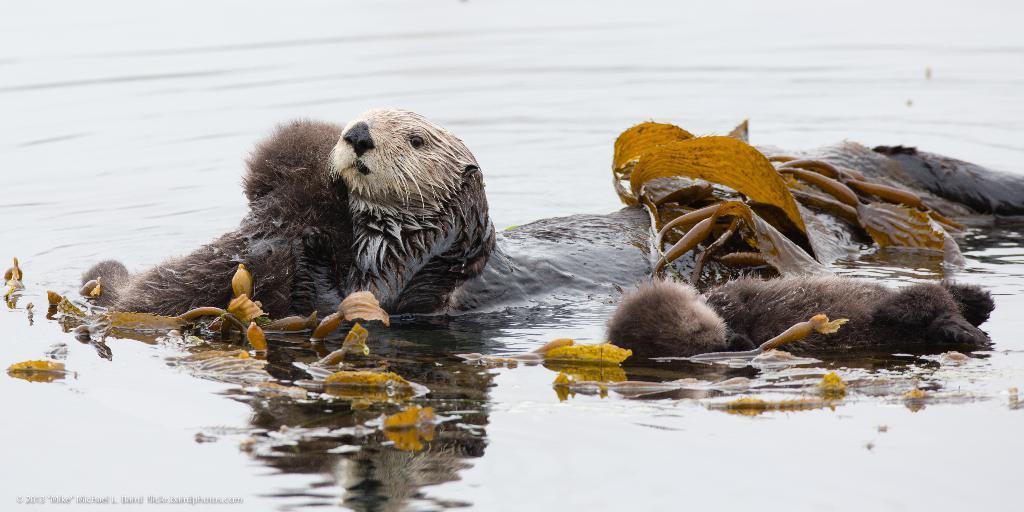Please provide a concise description of this image. In this image we can see animals and leaves on the water. 